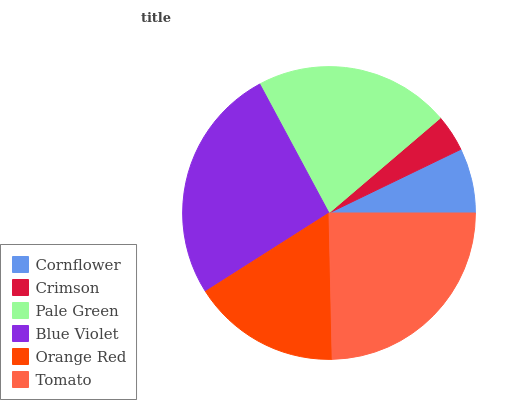Is Crimson the minimum?
Answer yes or no. Yes. Is Blue Violet the maximum?
Answer yes or no. Yes. Is Pale Green the minimum?
Answer yes or no. No. Is Pale Green the maximum?
Answer yes or no. No. Is Pale Green greater than Crimson?
Answer yes or no. Yes. Is Crimson less than Pale Green?
Answer yes or no. Yes. Is Crimson greater than Pale Green?
Answer yes or no. No. Is Pale Green less than Crimson?
Answer yes or no. No. Is Pale Green the high median?
Answer yes or no. Yes. Is Orange Red the low median?
Answer yes or no. Yes. Is Blue Violet the high median?
Answer yes or no. No. Is Tomato the low median?
Answer yes or no. No. 